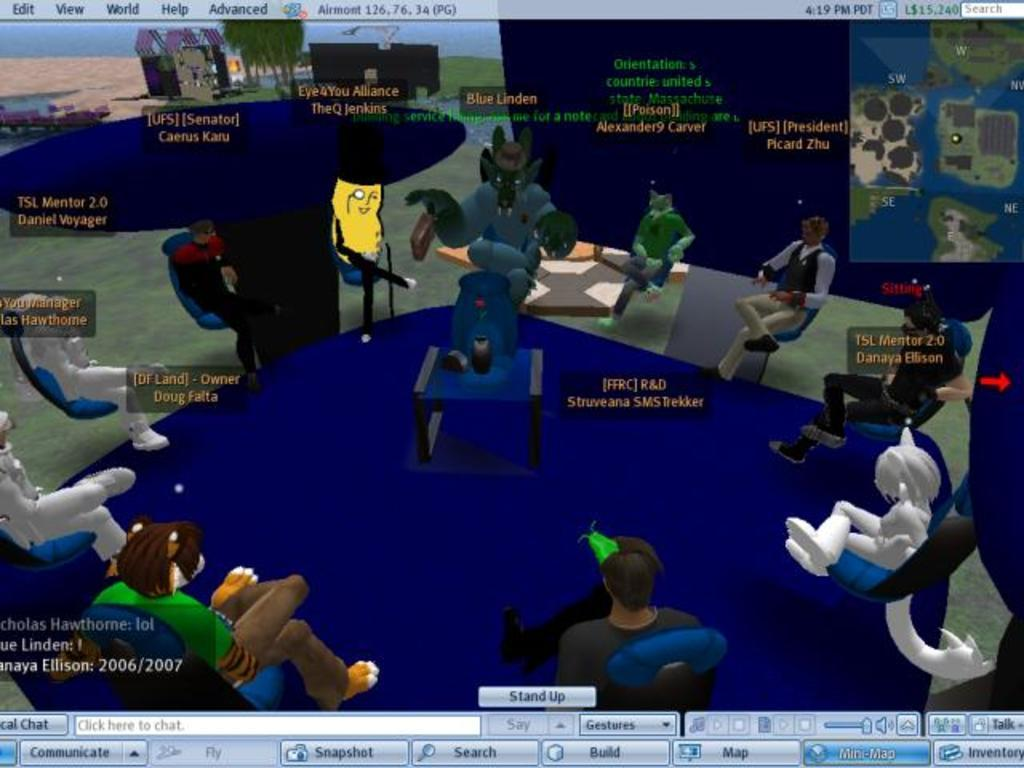What is displayed on the monitor screen in the image? There is an animation image on the monitor screen. Can you describe the animated characters in the image? There are animated cartoons sitting on a chair in the image. What can be seen in the background of the image? Trees and a building are visible in the background. What type of cheese is being used to create the animation on the monitor screen? There is no cheese present in the image; it features an animation on a monitor screen. What form does the bomb take in the image? There is no bomb present in the image. 